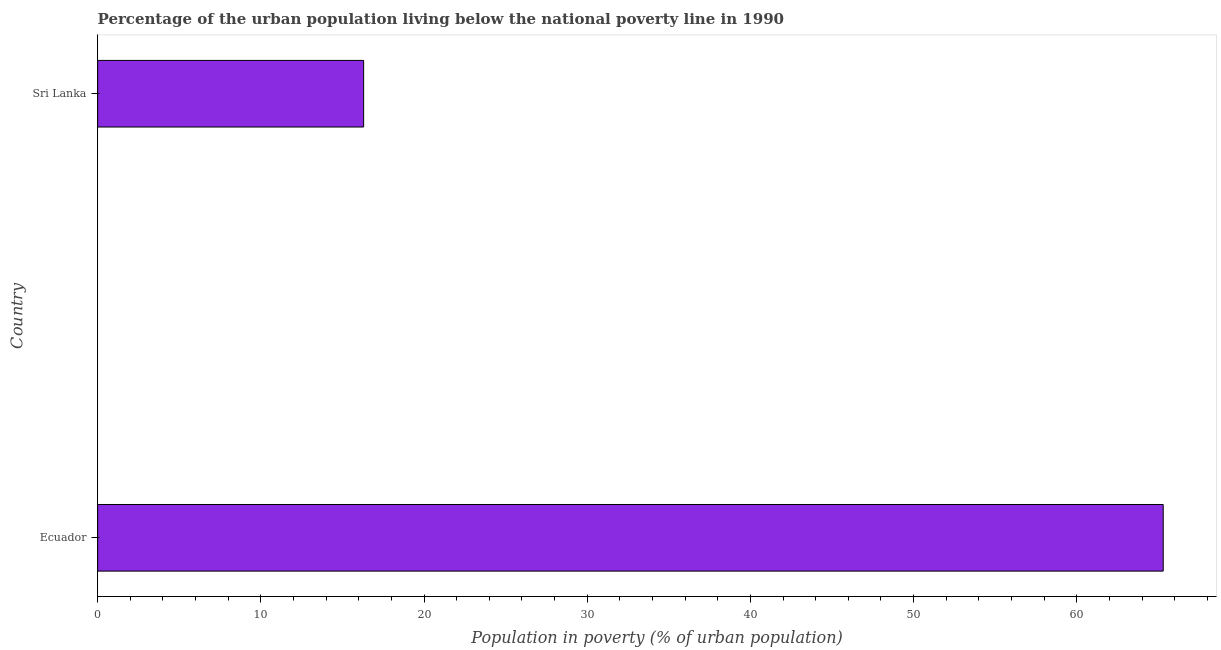Does the graph contain any zero values?
Ensure brevity in your answer.  No. What is the title of the graph?
Provide a succinct answer. Percentage of the urban population living below the national poverty line in 1990. What is the label or title of the X-axis?
Your response must be concise. Population in poverty (% of urban population). Across all countries, what is the maximum percentage of urban population living below poverty line?
Keep it short and to the point. 65.3. In which country was the percentage of urban population living below poverty line maximum?
Offer a terse response. Ecuador. In which country was the percentage of urban population living below poverty line minimum?
Your response must be concise. Sri Lanka. What is the sum of the percentage of urban population living below poverty line?
Ensure brevity in your answer.  81.6. What is the average percentage of urban population living below poverty line per country?
Offer a very short reply. 40.8. What is the median percentage of urban population living below poverty line?
Ensure brevity in your answer.  40.8. In how many countries, is the percentage of urban population living below poverty line greater than 66 %?
Your response must be concise. 0. What is the ratio of the percentage of urban population living below poverty line in Ecuador to that in Sri Lanka?
Provide a succinct answer. 4.01. How many bars are there?
Provide a succinct answer. 2. Are all the bars in the graph horizontal?
Provide a succinct answer. Yes. What is the difference between two consecutive major ticks on the X-axis?
Offer a very short reply. 10. Are the values on the major ticks of X-axis written in scientific E-notation?
Provide a succinct answer. No. What is the Population in poverty (% of urban population) of Ecuador?
Ensure brevity in your answer.  65.3. What is the Population in poverty (% of urban population) of Sri Lanka?
Provide a succinct answer. 16.3. What is the difference between the Population in poverty (% of urban population) in Ecuador and Sri Lanka?
Your response must be concise. 49. What is the ratio of the Population in poverty (% of urban population) in Ecuador to that in Sri Lanka?
Offer a terse response. 4.01. 